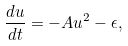Convert formula to latex. <formula><loc_0><loc_0><loc_500><loc_500>\frac { d u } { d t } = - A u ^ { 2 } - \epsilon ,</formula> 